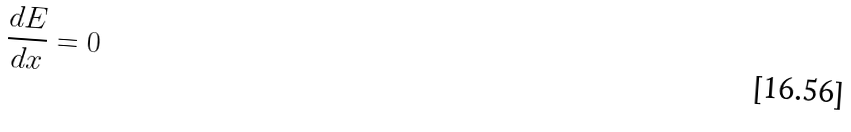Convert formula to latex. <formula><loc_0><loc_0><loc_500><loc_500>\frac { d E } { d x } = 0</formula> 